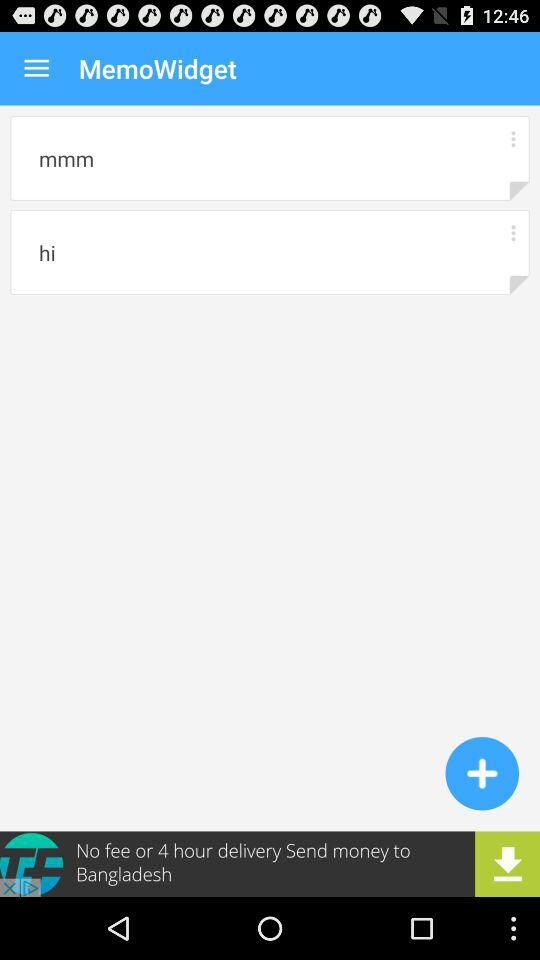What is the application name? The application name is "MemoWidget". 